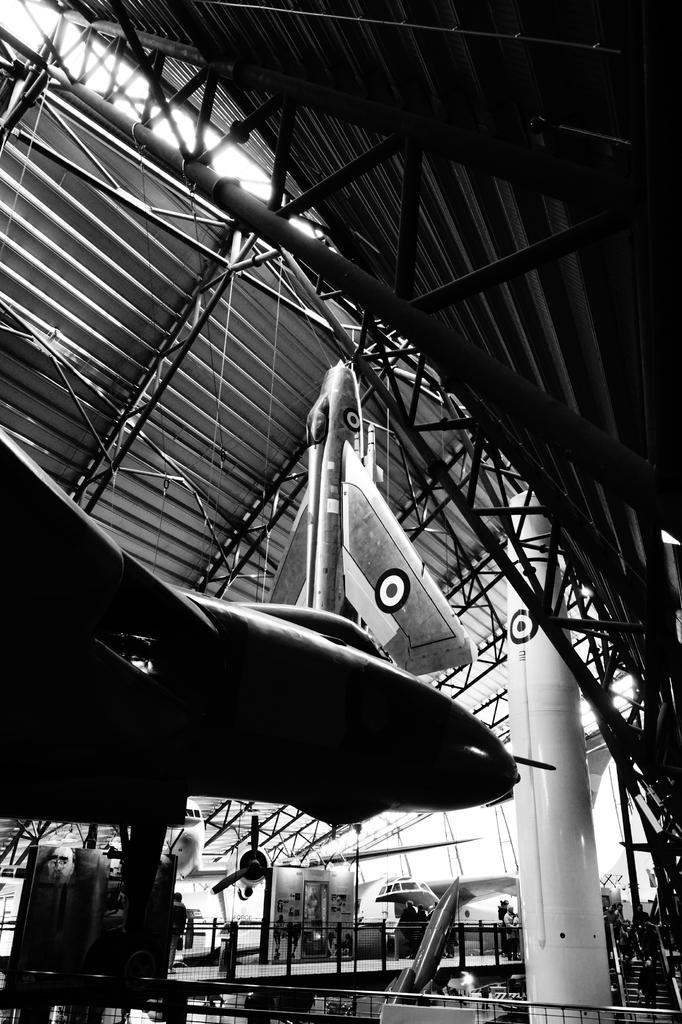What types of vehicles are present in the image? There are aircrafts and rockets in the image. Where are the aircrafts and rockets located? They are inside a metal shed. How is the metal shed supported? The metal shed is supported by rods. What type of stick can be seen in the image? There is no stick present in the image; it features aircrafts, rockets, and a metal shed. 